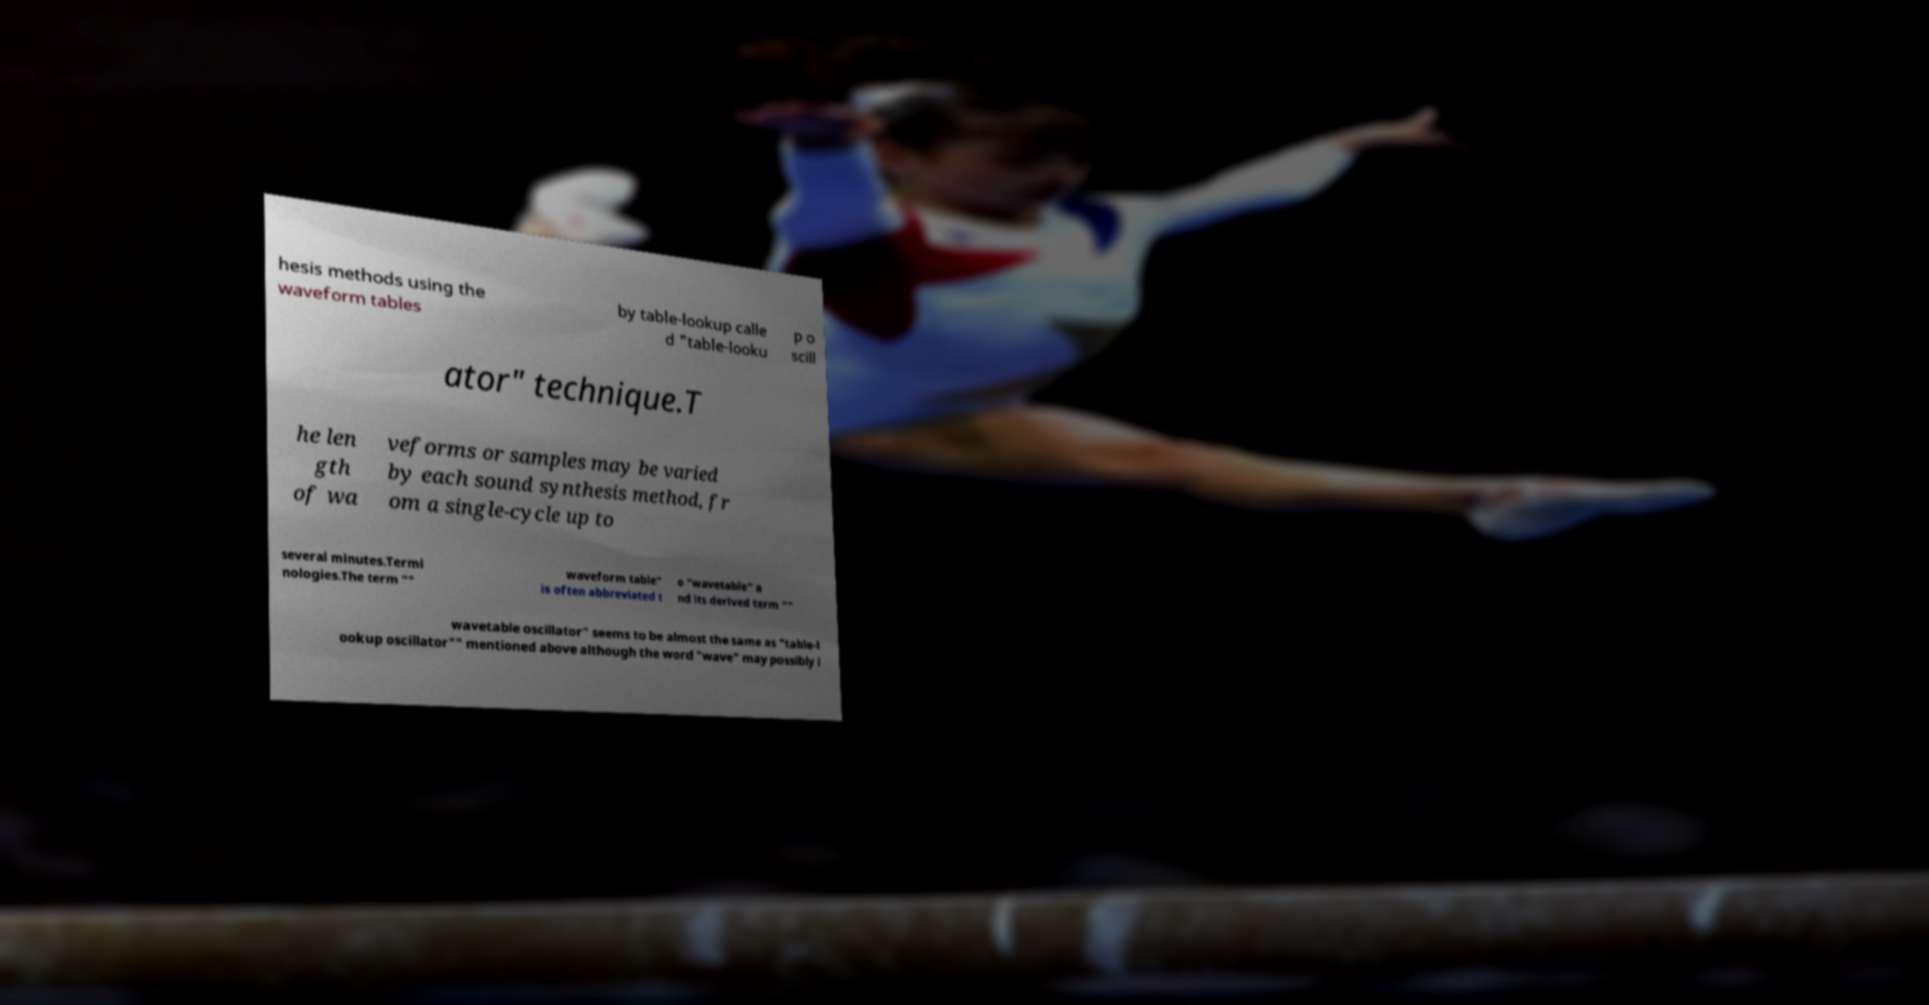Could you extract and type out the text from this image? hesis methods using the waveform tables by table-lookup calle d "table-looku p o scill ator" technique.T he len gth of wa veforms or samples may be varied by each sound synthesis method, fr om a single-cycle up to several minutes.Termi nologies.The term "" waveform table" is often abbreviated t o "wavetable" a nd its derived term "" wavetable oscillator" seems to be almost the same as "table-l ookup oscillator"" mentioned above although the word "wave" may possibly i 